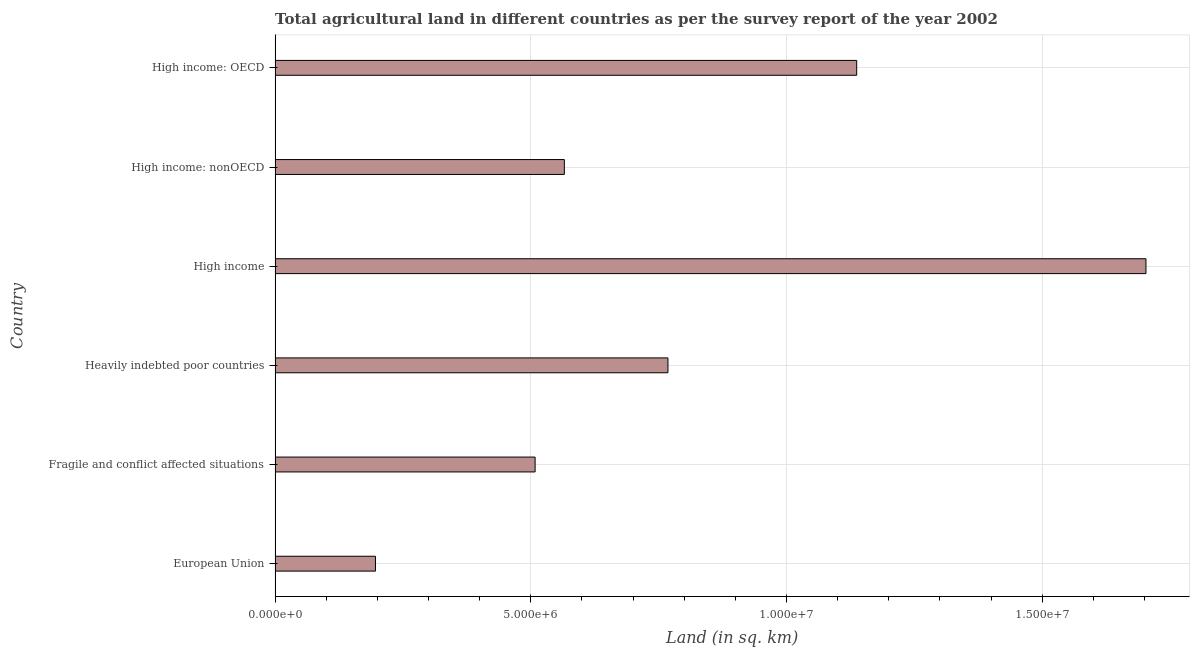Does the graph contain any zero values?
Your answer should be compact. No. What is the title of the graph?
Make the answer very short. Total agricultural land in different countries as per the survey report of the year 2002. What is the label or title of the X-axis?
Provide a short and direct response. Land (in sq. km). What is the agricultural land in High income: OECD?
Ensure brevity in your answer.  1.14e+07. Across all countries, what is the maximum agricultural land?
Provide a succinct answer. 1.70e+07. Across all countries, what is the minimum agricultural land?
Keep it short and to the point. 1.96e+06. What is the sum of the agricultural land?
Ensure brevity in your answer.  4.88e+07. What is the difference between the agricultural land in Fragile and conflict affected situations and High income: nonOECD?
Make the answer very short. -5.72e+05. What is the average agricultural land per country?
Your answer should be compact. 8.13e+06. What is the median agricultural land?
Provide a succinct answer. 6.67e+06. In how many countries, is the agricultural land greater than 8000000 sq. km?
Keep it short and to the point. 2. What is the ratio of the agricultural land in High income to that in High income: nonOECD?
Give a very brief answer. 3.01. Is the difference between the agricultural land in High income and High income: nonOECD greater than the difference between any two countries?
Make the answer very short. No. What is the difference between the highest and the second highest agricultural land?
Make the answer very short. 5.66e+06. Is the sum of the agricultural land in Fragile and conflict affected situations and High income: nonOECD greater than the maximum agricultural land across all countries?
Ensure brevity in your answer.  No. What is the difference between the highest and the lowest agricultural land?
Keep it short and to the point. 1.51e+07. In how many countries, is the agricultural land greater than the average agricultural land taken over all countries?
Offer a terse response. 2. Are all the bars in the graph horizontal?
Offer a terse response. Yes. How many countries are there in the graph?
Offer a very short reply. 6. Are the values on the major ticks of X-axis written in scientific E-notation?
Ensure brevity in your answer.  Yes. What is the Land (in sq. km) of European Union?
Offer a terse response. 1.96e+06. What is the Land (in sq. km) in Fragile and conflict affected situations?
Offer a very short reply. 5.09e+06. What is the Land (in sq. km) in Heavily indebted poor countries?
Your answer should be compact. 7.68e+06. What is the Land (in sq. km) in High income?
Offer a very short reply. 1.70e+07. What is the Land (in sq. km) of High income: nonOECD?
Offer a very short reply. 5.66e+06. What is the Land (in sq. km) in High income: OECD?
Offer a terse response. 1.14e+07. What is the difference between the Land (in sq. km) in European Union and Fragile and conflict affected situations?
Offer a very short reply. -3.12e+06. What is the difference between the Land (in sq. km) in European Union and Heavily indebted poor countries?
Provide a short and direct response. -5.72e+06. What is the difference between the Land (in sq. km) in European Union and High income?
Your answer should be very brief. -1.51e+07. What is the difference between the Land (in sq. km) in European Union and High income: nonOECD?
Your answer should be very brief. -3.69e+06. What is the difference between the Land (in sq. km) in European Union and High income: OECD?
Keep it short and to the point. -9.41e+06. What is the difference between the Land (in sq. km) in Fragile and conflict affected situations and Heavily indebted poor countries?
Your answer should be compact. -2.60e+06. What is the difference between the Land (in sq. km) in Fragile and conflict affected situations and High income?
Your response must be concise. -1.19e+07. What is the difference between the Land (in sq. km) in Fragile and conflict affected situations and High income: nonOECD?
Provide a succinct answer. -5.72e+05. What is the difference between the Land (in sq. km) in Fragile and conflict affected situations and High income: OECD?
Offer a very short reply. -6.29e+06. What is the difference between the Land (in sq. km) in Heavily indebted poor countries and High income?
Provide a short and direct response. -9.35e+06. What is the difference between the Land (in sq. km) in Heavily indebted poor countries and High income: nonOECD?
Make the answer very short. 2.03e+06. What is the difference between the Land (in sq. km) in Heavily indebted poor countries and High income: OECD?
Provide a succinct answer. -3.69e+06. What is the difference between the Land (in sq. km) in High income and High income: nonOECD?
Offer a very short reply. 1.14e+07. What is the difference between the Land (in sq. km) in High income and High income: OECD?
Provide a succinct answer. 5.66e+06. What is the difference between the Land (in sq. km) in High income: nonOECD and High income: OECD?
Ensure brevity in your answer.  -5.72e+06. What is the ratio of the Land (in sq. km) in European Union to that in Fragile and conflict affected situations?
Offer a very short reply. 0.39. What is the ratio of the Land (in sq. km) in European Union to that in Heavily indebted poor countries?
Provide a succinct answer. 0.26. What is the ratio of the Land (in sq. km) in European Union to that in High income?
Ensure brevity in your answer.  0.12. What is the ratio of the Land (in sq. km) in European Union to that in High income: nonOECD?
Provide a succinct answer. 0.35. What is the ratio of the Land (in sq. km) in European Union to that in High income: OECD?
Keep it short and to the point. 0.17. What is the ratio of the Land (in sq. km) in Fragile and conflict affected situations to that in Heavily indebted poor countries?
Provide a short and direct response. 0.66. What is the ratio of the Land (in sq. km) in Fragile and conflict affected situations to that in High income?
Offer a very short reply. 0.3. What is the ratio of the Land (in sq. km) in Fragile and conflict affected situations to that in High income: nonOECD?
Provide a short and direct response. 0.9. What is the ratio of the Land (in sq. km) in Fragile and conflict affected situations to that in High income: OECD?
Give a very brief answer. 0.45. What is the ratio of the Land (in sq. km) in Heavily indebted poor countries to that in High income?
Offer a terse response. 0.45. What is the ratio of the Land (in sq. km) in Heavily indebted poor countries to that in High income: nonOECD?
Make the answer very short. 1.36. What is the ratio of the Land (in sq. km) in Heavily indebted poor countries to that in High income: OECD?
Make the answer very short. 0.68. What is the ratio of the Land (in sq. km) in High income to that in High income: nonOECD?
Offer a terse response. 3.01. What is the ratio of the Land (in sq. km) in High income to that in High income: OECD?
Make the answer very short. 1.5. What is the ratio of the Land (in sq. km) in High income: nonOECD to that in High income: OECD?
Your answer should be very brief. 0.5. 